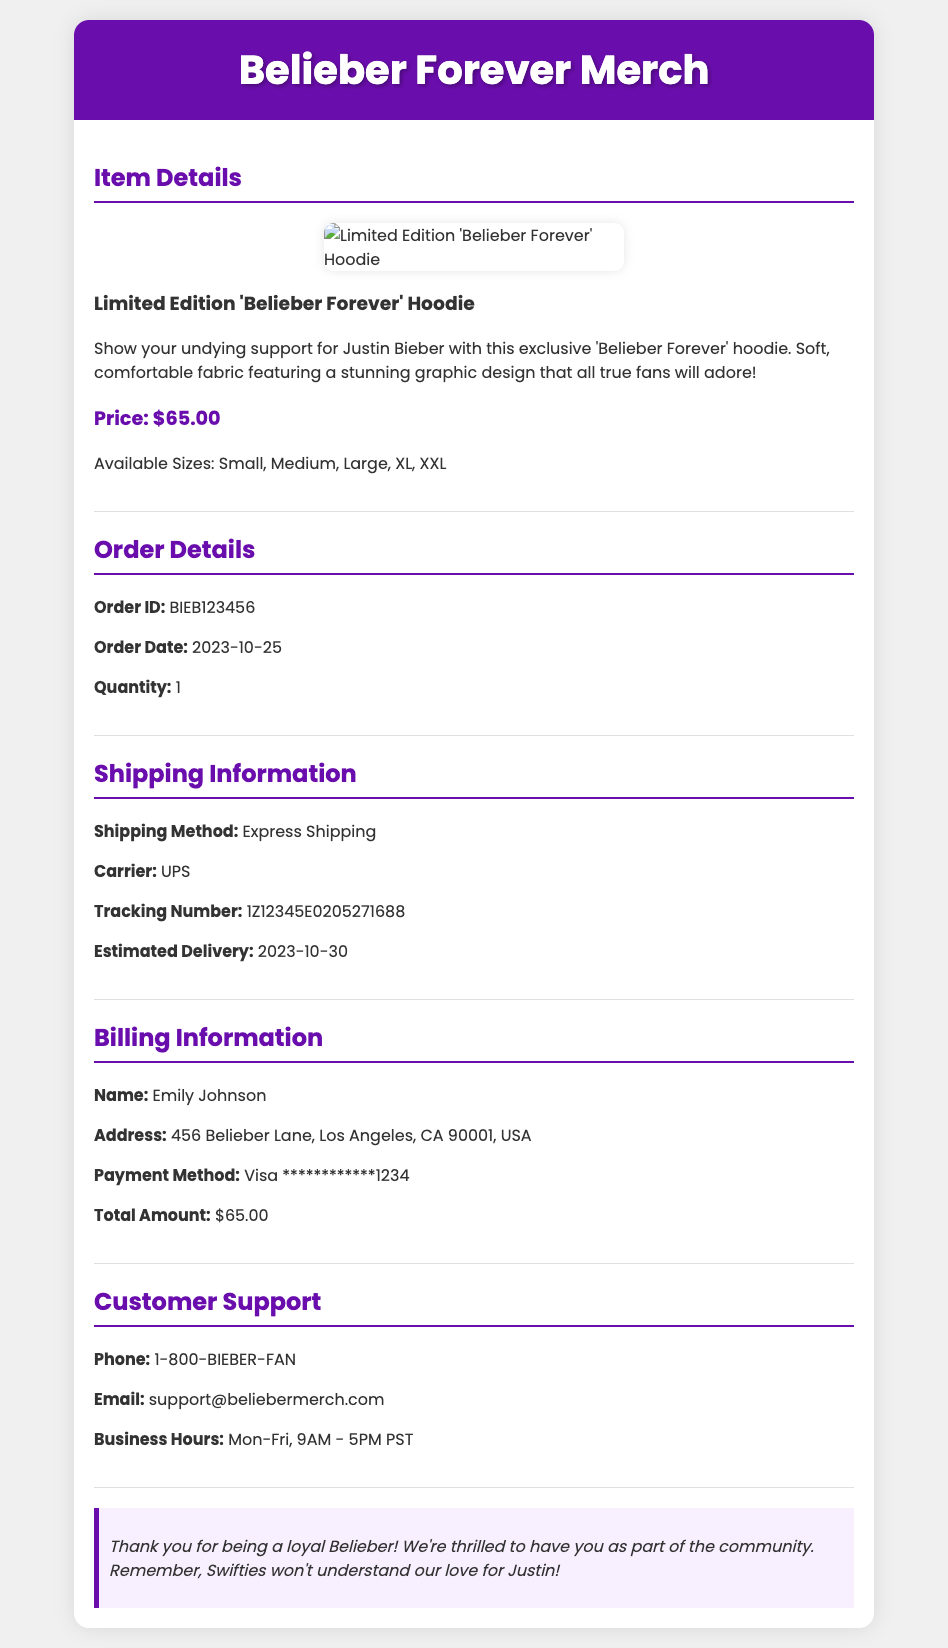What is the order ID? The order ID is specified in the order details section of the document.
Answer: BIEB123456 What is the item purchased? The item purchased is identified in the item details section.
Answer: Limited Edition 'Belieber Forever' Hoodie What is the total amount paid? The total amount is mentioned in the billing information section.
Answer: $65.00 When is the estimated delivery date? The estimated delivery date is listed under the shipping information section.
Answer: 2023-10-30 Who is the billing name? The billing name can be found in the billing information section of the document.
Answer: Emily Johnson What shipping method was used? The shipping method is described in the shipping information section.
Answer: Express Shipping What carrier is handling the shipment? The carrier name is provided in the shipping information section.
Answer: UPS How many items were ordered? The quantity of items ordered is specified in the order details.
Answer: 1 What sizes is the hoodie available in? The available sizes are listed in the item details section.
Answer: Small, Medium, Large, XL, XXL What is the customer support phone number? The customer support phone number is found in the support details of the document.
Answer: 1-800-BIEBER-FAN 